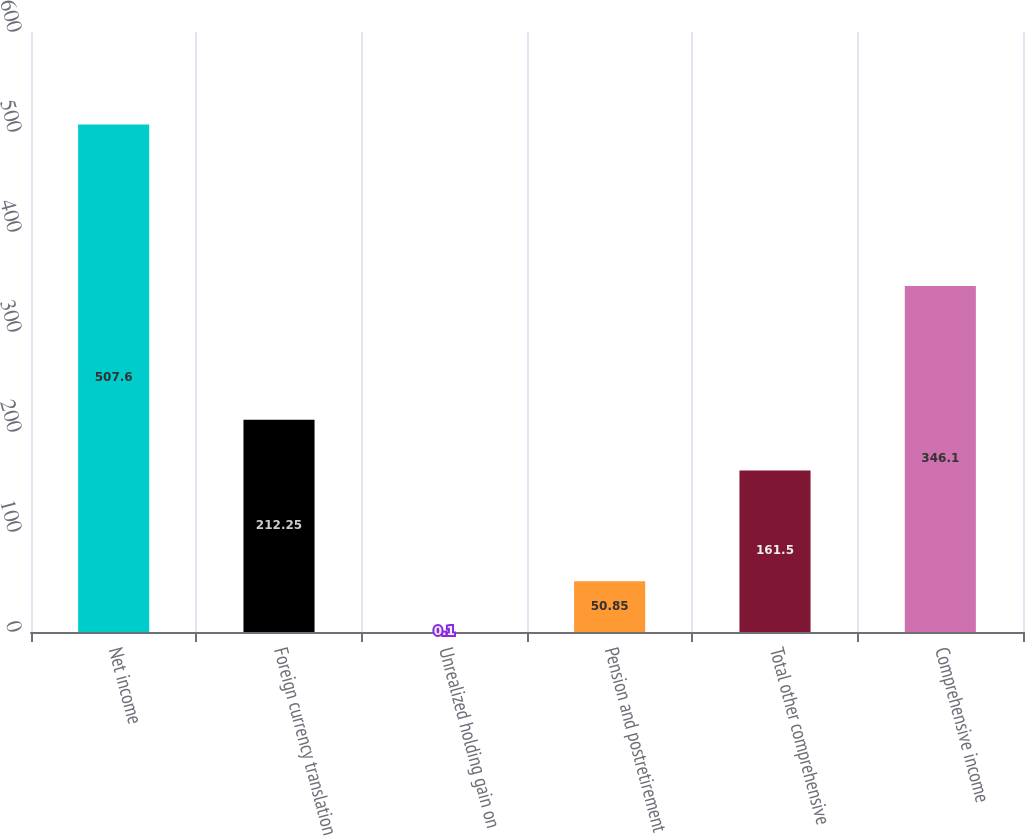<chart> <loc_0><loc_0><loc_500><loc_500><bar_chart><fcel>Net income<fcel>Foreign currency translation<fcel>Unrealized holding gain on<fcel>Pension and postretirement<fcel>Total other comprehensive<fcel>Comprehensive income<nl><fcel>507.6<fcel>212.25<fcel>0.1<fcel>50.85<fcel>161.5<fcel>346.1<nl></chart> 